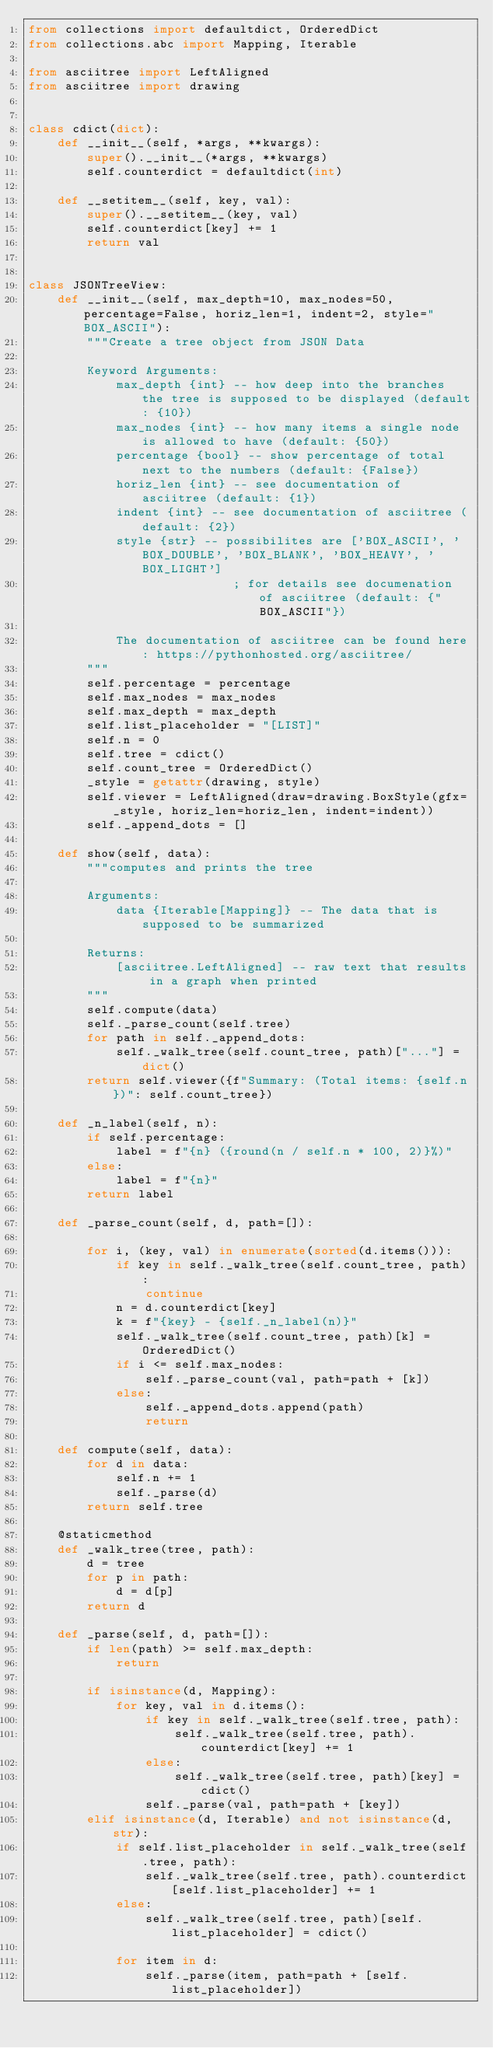Convert code to text. <code><loc_0><loc_0><loc_500><loc_500><_Python_>from collections import defaultdict, OrderedDict
from collections.abc import Mapping, Iterable

from asciitree import LeftAligned
from asciitree import drawing


class cdict(dict):
    def __init__(self, *args, **kwargs):
        super().__init__(*args, **kwargs)
        self.counterdict = defaultdict(int)

    def __setitem__(self, key, val):
        super().__setitem__(key, val)
        self.counterdict[key] += 1
        return val


class JSONTreeView:
    def __init__(self, max_depth=10, max_nodes=50, percentage=False, horiz_len=1, indent=2, style="BOX_ASCII"):
        """Create a tree object from JSON Data

        Keyword Arguments:
            max_depth {int} -- how deep into the branches the tree is supposed to be displayed (default: {10})
            max_nodes {int} -- how many items a single node is allowed to have (default: {50})
            percentage {bool} -- show percentage of total next to the numbers (default: {False})
            horiz_len {int} -- see documentation of asciitree (default: {1})
            indent {int} -- see documentation of asciitree (default: {2})
            style {str} -- possibilites are ['BOX_ASCII', 'BOX_DOUBLE', 'BOX_BLANK', 'BOX_HEAVY', 'BOX_LIGHT']
                            ; for details see documenation of asciitree (default: {"BOX_ASCII"})

            The documentation of asciitree can be found here: https://pythonhosted.org/asciitree/
        """
        self.percentage = percentage
        self.max_nodes = max_nodes
        self.max_depth = max_depth
        self.list_placeholder = "[LIST]"
        self.n = 0
        self.tree = cdict()
        self.count_tree = OrderedDict()
        _style = getattr(drawing, style)
        self.viewer = LeftAligned(draw=drawing.BoxStyle(gfx=_style, horiz_len=horiz_len, indent=indent))
        self._append_dots = []

    def show(self, data):
        """computes and prints the tree

        Arguments:
            data {Iterable[Mapping]} -- The data that is supposed to be summarized

        Returns:
            [asciitree.LeftAligned] -- raw text that results in a graph when printed
        """
        self.compute(data)
        self._parse_count(self.tree)
        for path in self._append_dots:
            self._walk_tree(self.count_tree, path)["..."] = dict()
        return self.viewer({f"Summary: (Total items: {self.n})": self.count_tree})

    def _n_label(self, n):
        if self.percentage:
            label = f"{n} ({round(n / self.n * 100, 2)}%)"
        else:
            label = f"{n}"
        return label

    def _parse_count(self, d, path=[]):

        for i, (key, val) in enumerate(sorted(d.items())):
            if key in self._walk_tree(self.count_tree, path):
                continue
            n = d.counterdict[key]
            k = f"{key} - {self._n_label(n)}"
            self._walk_tree(self.count_tree, path)[k] = OrderedDict()
            if i <= self.max_nodes:
                self._parse_count(val, path=path + [k])
            else:
                self._append_dots.append(path)
                return

    def compute(self, data):
        for d in data:
            self.n += 1
            self._parse(d)
        return self.tree

    @staticmethod
    def _walk_tree(tree, path):
        d = tree
        for p in path:
            d = d[p]
        return d

    def _parse(self, d, path=[]):
        if len(path) >= self.max_depth:
            return

        if isinstance(d, Mapping):
            for key, val in d.items():
                if key in self._walk_tree(self.tree, path):
                    self._walk_tree(self.tree, path).counterdict[key] += 1
                else:
                    self._walk_tree(self.tree, path)[key] = cdict()
                self._parse(val, path=path + [key])
        elif isinstance(d, Iterable) and not isinstance(d, str):
            if self.list_placeholder in self._walk_tree(self.tree, path):
                self._walk_tree(self.tree, path).counterdict[self.list_placeholder] += 1
            else:
                self._walk_tree(self.tree, path)[self.list_placeholder] = cdict()

            for item in d:
                self._parse(item, path=path + [self.list_placeholder])
</code> 